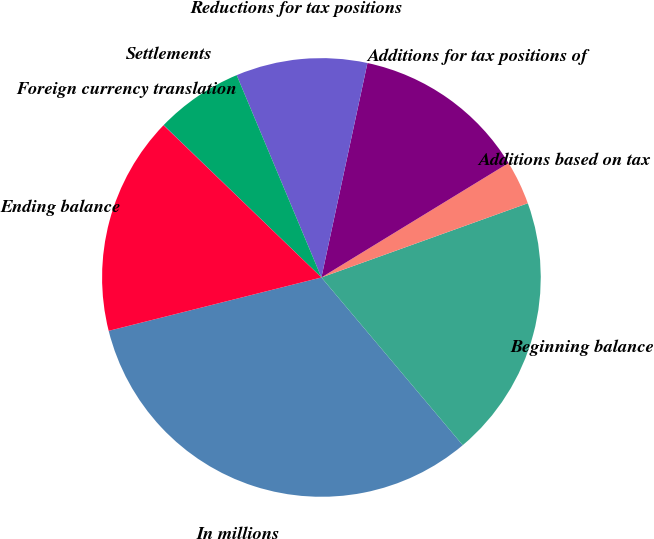Convert chart to OTSL. <chart><loc_0><loc_0><loc_500><loc_500><pie_chart><fcel>In millions<fcel>Beginning balance<fcel>Additions based on tax<fcel>Additions for tax positions of<fcel>Reductions for tax positions<fcel>Settlements<fcel>Foreign currency translation<fcel>Ending balance<nl><fcel>32.23%<fcel>19.35%<fcel>3.24%<fcel>12.9%<fcel>9.68%<fcel>6.46%<fcel>0.02%<fcel>16.12%<nl></chart> 